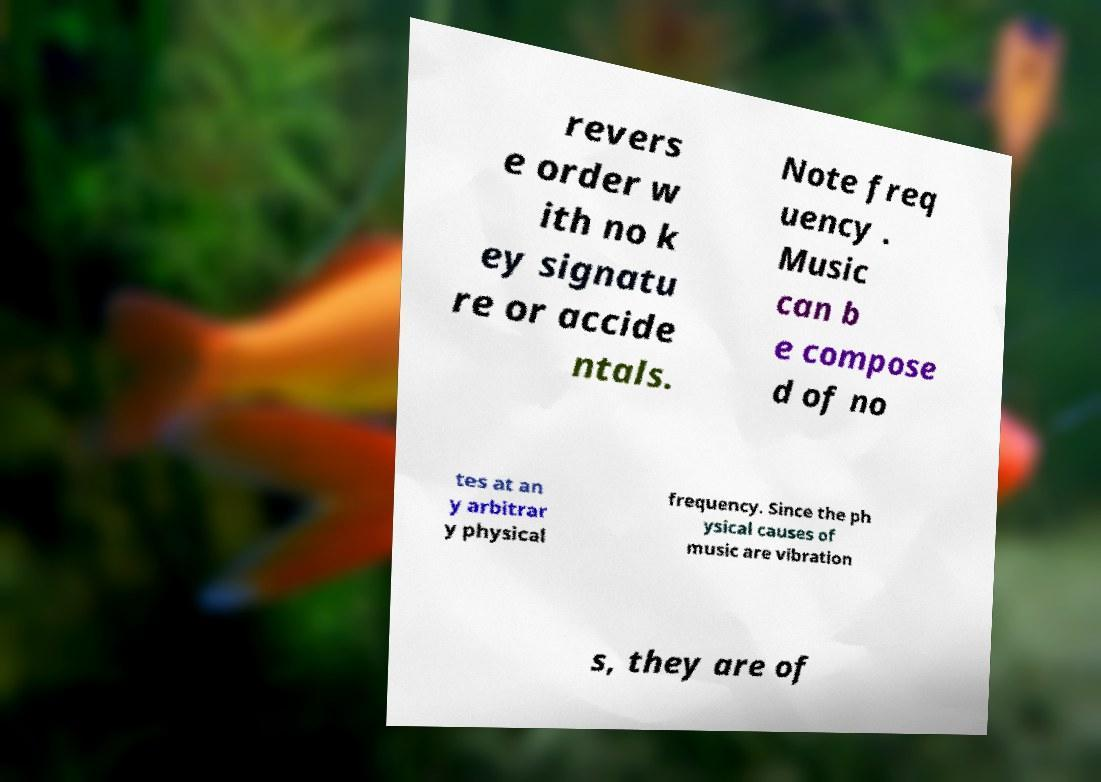I need the written content from this picture converted into text. Can you do that? revers e order w ith no k ey signatu re or accide ntals. Note freq uency . Music can b e compose d of no tes at an y arbitrar y physical frequency. Since the ph ysical causes of music are vibration s, they are of 